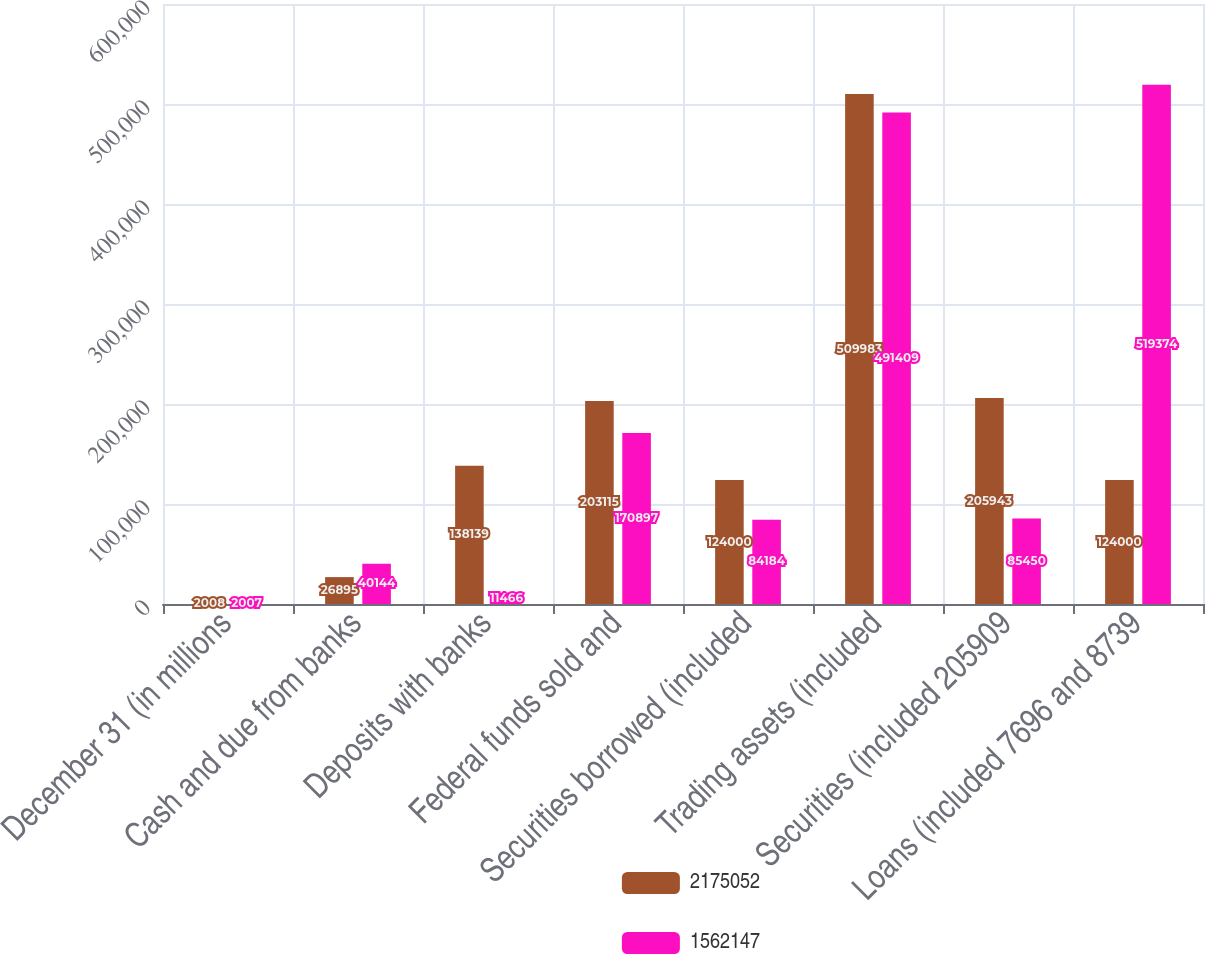Convert chart. <chart><loc_0><loc_0><loc_500><loc_500><stacked_bar_chart><ecel><fcel>December 31 (in millions<fcel>Cash and due from banks<fcel>Deposits with banks<fcel>Federal funds sold and<fcel>Securities borrowed (included<fcel>Trading assets (included<fcel>Securities (included 205909<fcel>Loans (included 7696 and 8739<nl><fcel>2.17505e+06<fcel>2008<fcel>26895<fcel>138139<fcel>203115<fcel>124000<fcel>509983<fcel>205943<fcel>124000<nl><fcel>1.56215e+06<fcel>2007<fcel>40144<fcel>11466<fcel>170897<fcel>84184<fcel>491409<fcel>85450<fcel>519374<nl></chart> 